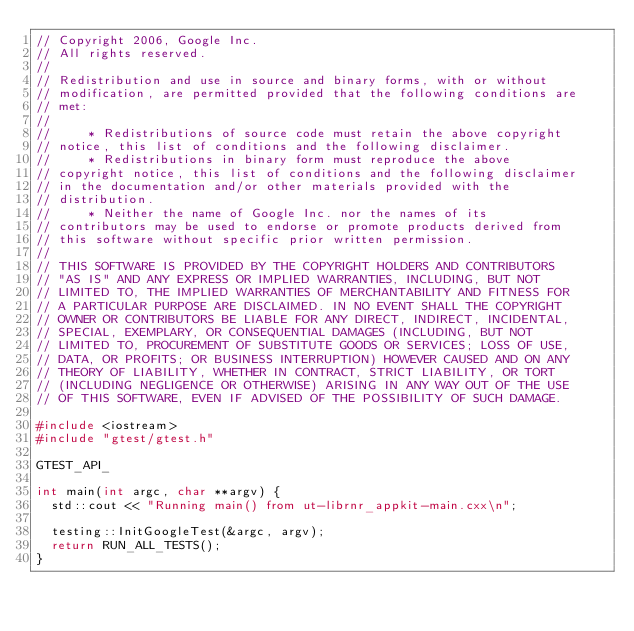<code> <loc_0><loc_0><loc_500><loc_500><_C++_>// Copyright 2006, Google Inc.
// All rights reserved.
//
// Redistribution and use in source and binary forms, with or without
// modification, are permitted provided that the following conditions are
// met:
//
//     * Redistributions of source code must retain the above copyright
// notice, this list of conditions and the following disclaimer.
//     * Redistributions in binary form must reproduce the above
// copyright notice, this list of conditions and the following disclaimer
// in the documentation and/or other materials provided with the
// distribution.
//     * Neither the name of Google Inc. nor the names of its
// contributors may be used to endorse or promote products derived from
// this software without specific prior written permission.
//
// THIS SOFTWARE IS PROVIDED BY THE COPYRIGHT HOLDERS AND CONTRIBUTORS
// "AS IS" AND ANY EXPRESS OR IMPLIED WARRANTIES, INCLUDING, BUT NOT
// LIMITED TO, THE IMPLIED WARRANTIES OF MERCHANTABILITY AND FITNESS FOR
// A PARTICULAR PURPOSE ARE DISCLAIMED. IN NO EVENT SHALL THE COPYRIGHT
// OWNER OR CONTRIBUTORS BE LIABLE FOR ANY DIRECT, INDIRECT, INCIDENTAL,
// SPECIAL, EXEMPLARY, OR CONSEQUENTIAL DAMAGES (INCLUDING, BUT NOT
// LIMITED TO, PROCUREMENT OF SUBSTITUTE GOODS OR SERVICES; LOSS OF USE,
// DATA, OR PROFITS; OR BUSINESS INTERRUPTION) HOWEVER CAUSED AND ON ANY
// THEORY OF LIABILITY, WHETHER IN CONTRACT, STRICT LIABILITY, OR TORT
// (INCLUDING NEGLIGENCE OR OTHERWISE) ARISING IN ANY WAY OUT OF THE USE
// OF THIS SOFTWARE, EVEN IF ADVISED OF THE POSSIBILITY OF SUCH DAMAGE.

#include <iostream>
#include "gtest/gtest.h"

GTEST_API_ 

int main(int argc, char **argv) {
  std::cout << "Running main() from ut-librnr_appkit-main.cxx\n";

  testing::InitGoogleTest(&argc, argv);
  return RUN_ALL_TESTS();
}
</code> 